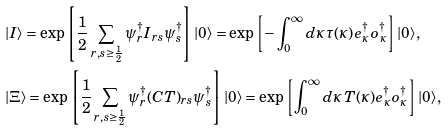Convert formula to latex. <formula><loc_0><loc_0><loc_500><loc_500>& | I \rangle = \exp \left [ \frac { 1 } { 2 } \sum _ { r , s \geq \frac { 1 } { 2 } } \psi _ { r } ^ { \dagger } I _ { r s } \psi _ { s } ^ { \dagger } \right ] | 0 \rangle = \exp \left [ - \int _ { 0 } ^ { \infty } d \kappa \, \tau ( \kappa ) e _ { \kappa } ^ { \dag } o _ { \kappa } ^ { \dag } \right ] | 0 \rangle , \\ & | \Xi \rangle = \exp \left [ \frac { 1 } { 2 } \sum _ { r , s \geq \frac { 1 } { 2 } } \psi _ { r } ^ { \dagger } ( C T ) _ { r s } \psi _ { s } ^ { \dagger } \right ] | 0 \rangle = \exp \left [ \int _ { 0 } ^ { \infty } d \kappa \, T ( \kappa ) e _ { \kappa } ^ { \dag } o _ { \kappa } ^ { \dag } \right ] | 0 \rangle ,</formula> 